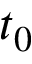Convert formula to latex. <formula><loc_0><loc_0><loc_500><loc_500>t _ { 0 }</formula> 